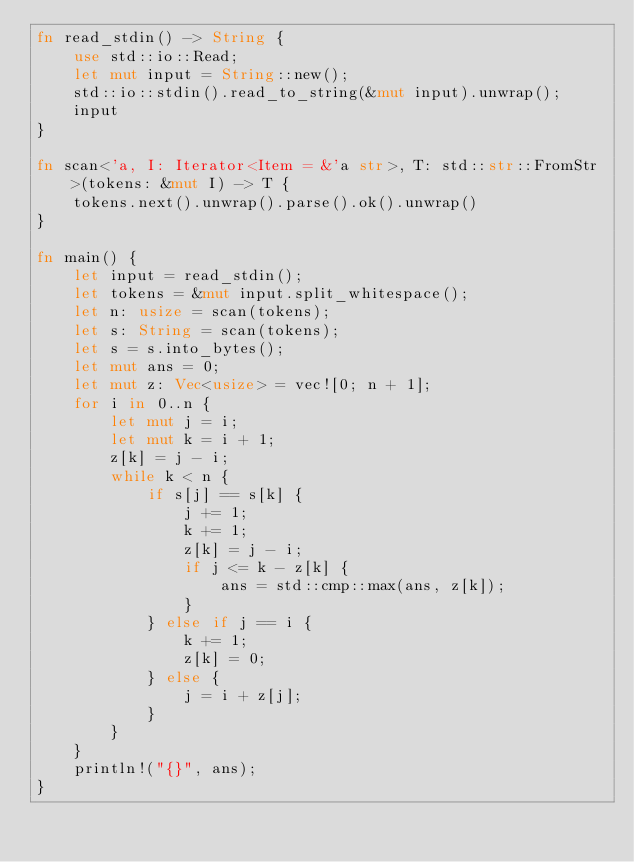<code> <loc_0><loc_0><loc_500><loc_500><_Rust_>fn read_stdin() -> String {
    use std::io::Read;
    let mut input = String::new();
    std::io::stdin().read_to_string(&mut input).unwrap();
    input
}

fn scan<'a, I: Iterator<Item = &'a str>, T: std::str::FromStr>(tokens: &mut I) -> T {
    tokens.next().unwrap().parse().ok().unwrap()
}

fn main() {
    let input = read_stdin();
    let tokens = &mut input.split_whitespace();
    let n: usize = scan(tokens);
    let s: String = scan(tokens);
    let s = s.into_bytes();
    let mut ans = 0;
    let mut z: Vec<usize> = vec![0; n + 1];
    for i in 0..n {
        let mut j = i;
        let mut k = i + 1;
        z[k] = j - i;
        while k < n {
            if s[j] == s[k] {
                j += 1;
                k += 1;
                z[k] = j - i;
                if j <= k - z[k] {
                    ans = std::cmp::max(ans, z[k]);
                }
            } else if j == i {
                k += 1;
                z[k] = 0;
            } else {
                j = i + z[j];
            }
        }
    }
    println!("{}", ans);
}
</code> 